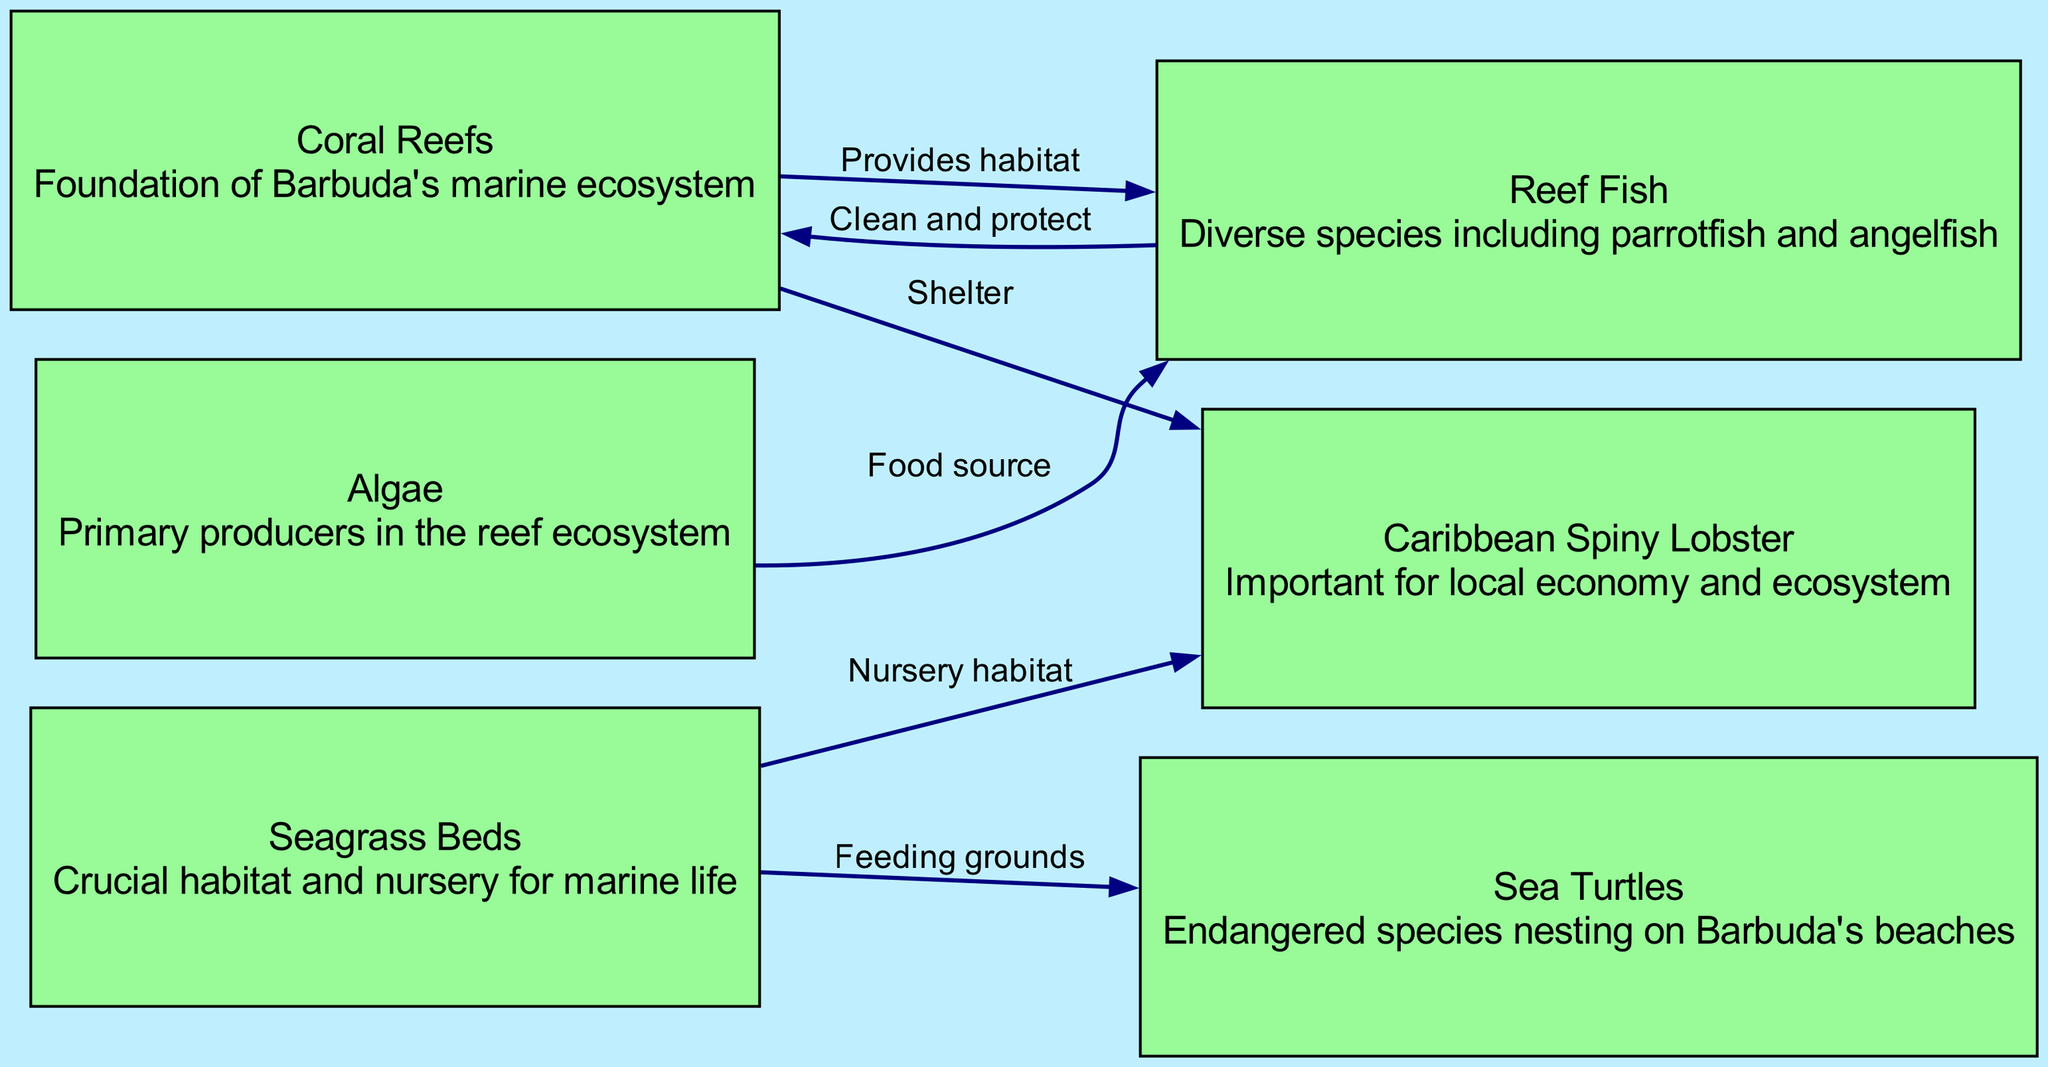What is the foundation of Barbuda's marine ecosystem? The diagram identifies “Coral Reefs” as the foundation of the marine ecosystem in Barbuda, as it is labeled directly in the node with that description.
Answer: Coral Reefs How many nodes are in the diagram? By counting the unique entities presented in the nodes section of the diagram, there is a total of six distinct nodes: Coral Reefs, Reef Fish, Caribbean Spiny Lobster, Seagrass Beds, Sea Turtles, and Algae.
Answer: Six What does the coral provide for the fish? The diagram states that "Coral" provides "habitat" for "fish," as indicated by the directed edge connecting these two nodes with this specific label.
Answer: Habitat What connects seagrass beds to lobsters? The direct relationship is represented by the edge labeled "Nursery habitat," which illustrates the role of seagrass in providing a crucial environment for lobsters.
Answer: Nursery habitat Which species relies on seagrass as feeding grounds? According to the diagram, "Sea Turtles" rely on "Seagrass Beds" as their feeding grounds, as indicated by the directed edge connecting these two entities with that specific label.
Answer: Sea Turtles What is the food source for reef fish? The diagram specifies "Algae" as the food source for "Reef Fish," clearly denoted by the directed edge labeled "Food source."
Answer: Algae What is the relationship between coral and lobster? The diagram notes that "Coral" provides "Shelter" for "Lobster," shown by the directed edge between these two nodes explicitly labeled as such.
Answer: Shelter How many edges are there in total connecting the nodes? Counting each directed relationship drawn on the diagram, there are a total of six distinct edges present in the data, connecting the various nodes together.
Answer: Six What role do algae play in the reef ecosystem? The diagram indicates that "Algae" serve as "Primary producers" in the reef ecosystem; thus, they are fundamental to sustaining the marine food web shown in the diagram.
Answer: Primary producers 